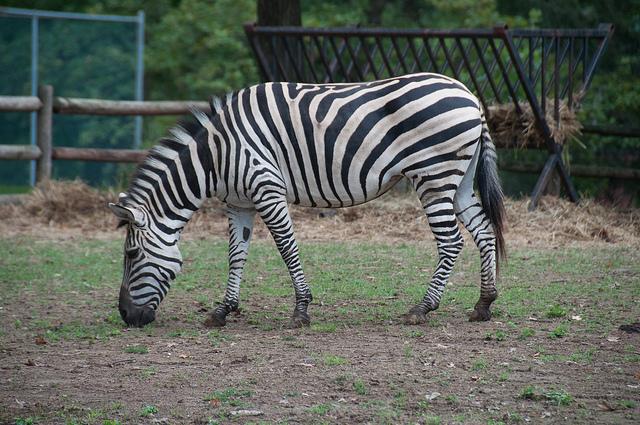How many zebras do you see?
Be succinct. 1. Is this zebra in a cage?
Concise answer only. No. Is the zebra sniffing the grass?
Give a very brief answer. Yes. Which animal is this?
Answer briefly. Zebra. How many different types of animals are there?
Quick response, please. 1. How many zebras are there?
Short answer required. 1. Is the zebra wild?
Write a very short answer. No. Does the animal have spots?
Answer briefly. No. How many animals are present?
Be succinct. 1. How many animals are shown?
Give a very brief answer. 1. What is cast?
Write a very short answer. Nothing. What is the fence made out of?
Quick response, please. Wood. What way are the animals facing?
Short answer required. Left. How many stripes are there?
Short answer required. Many. How can you tell the animal is in a zoo?
Concise answer only. Fence. How many of these animals are there?
Be succinct. 1. How many zebras in the photo?
Write a very short answer. 1. How many stripes does the zebra have?
Be succinct. 50. Does this zebra live in captivity?
Concise answer only. Yes. 